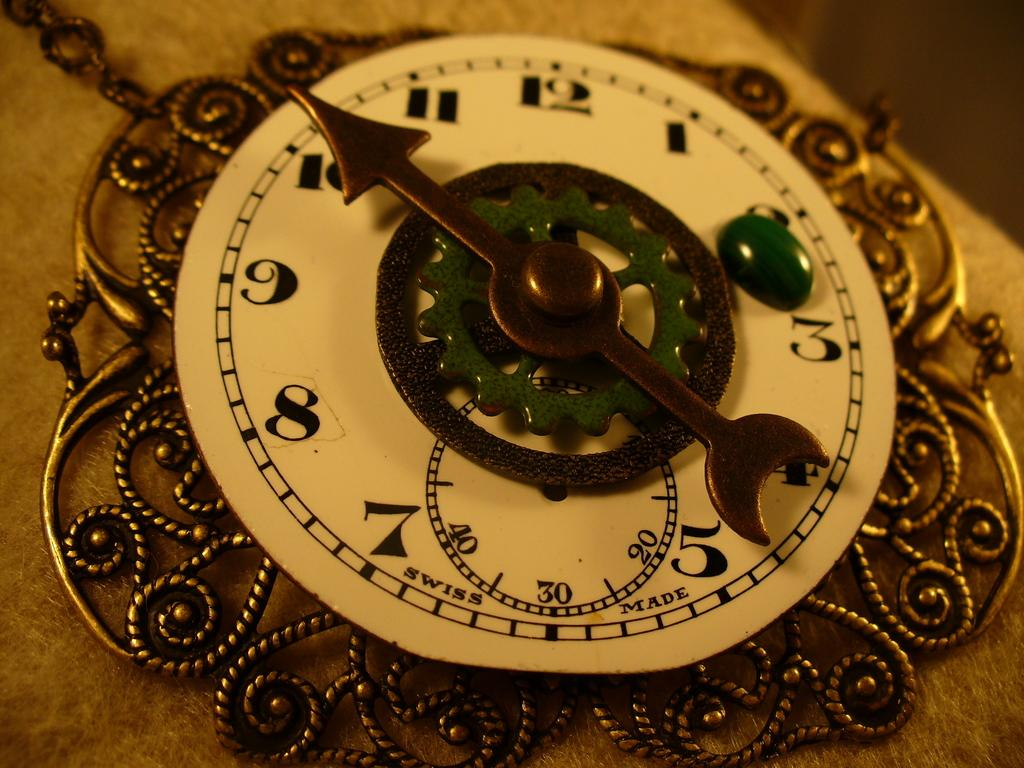<image>
Share a concise interpretation of the image provided. A clock features the phrase "Swiss Made" printed on the face. 